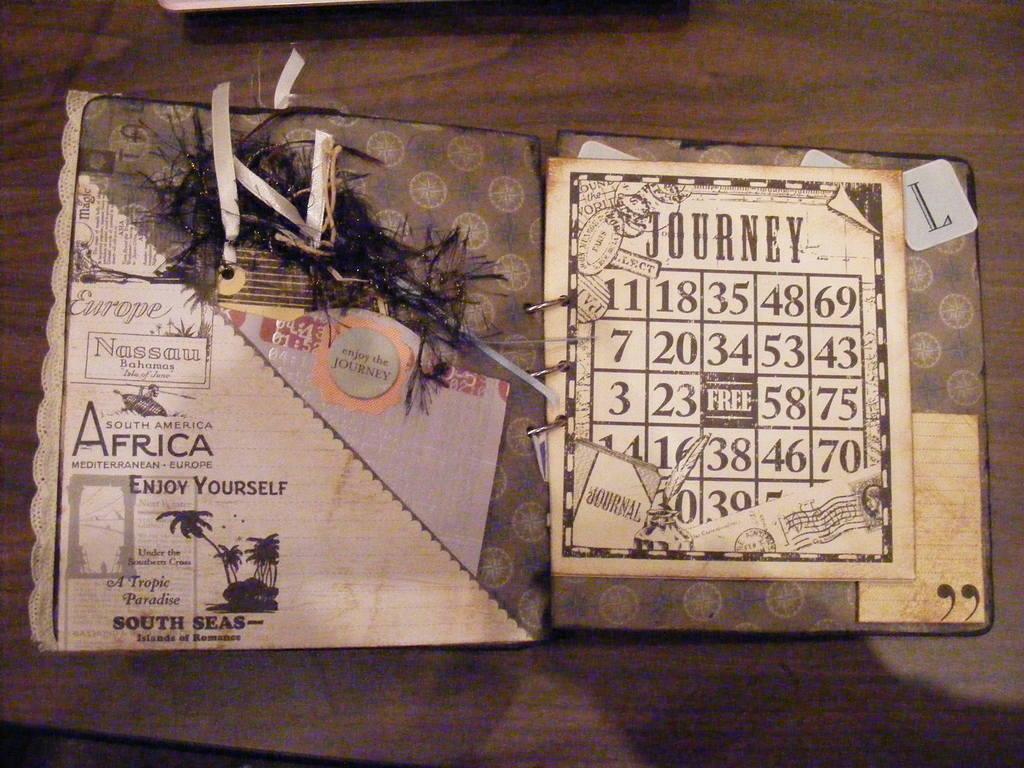What is written on the right side at the top?
Your answer should be compact. Journey. 